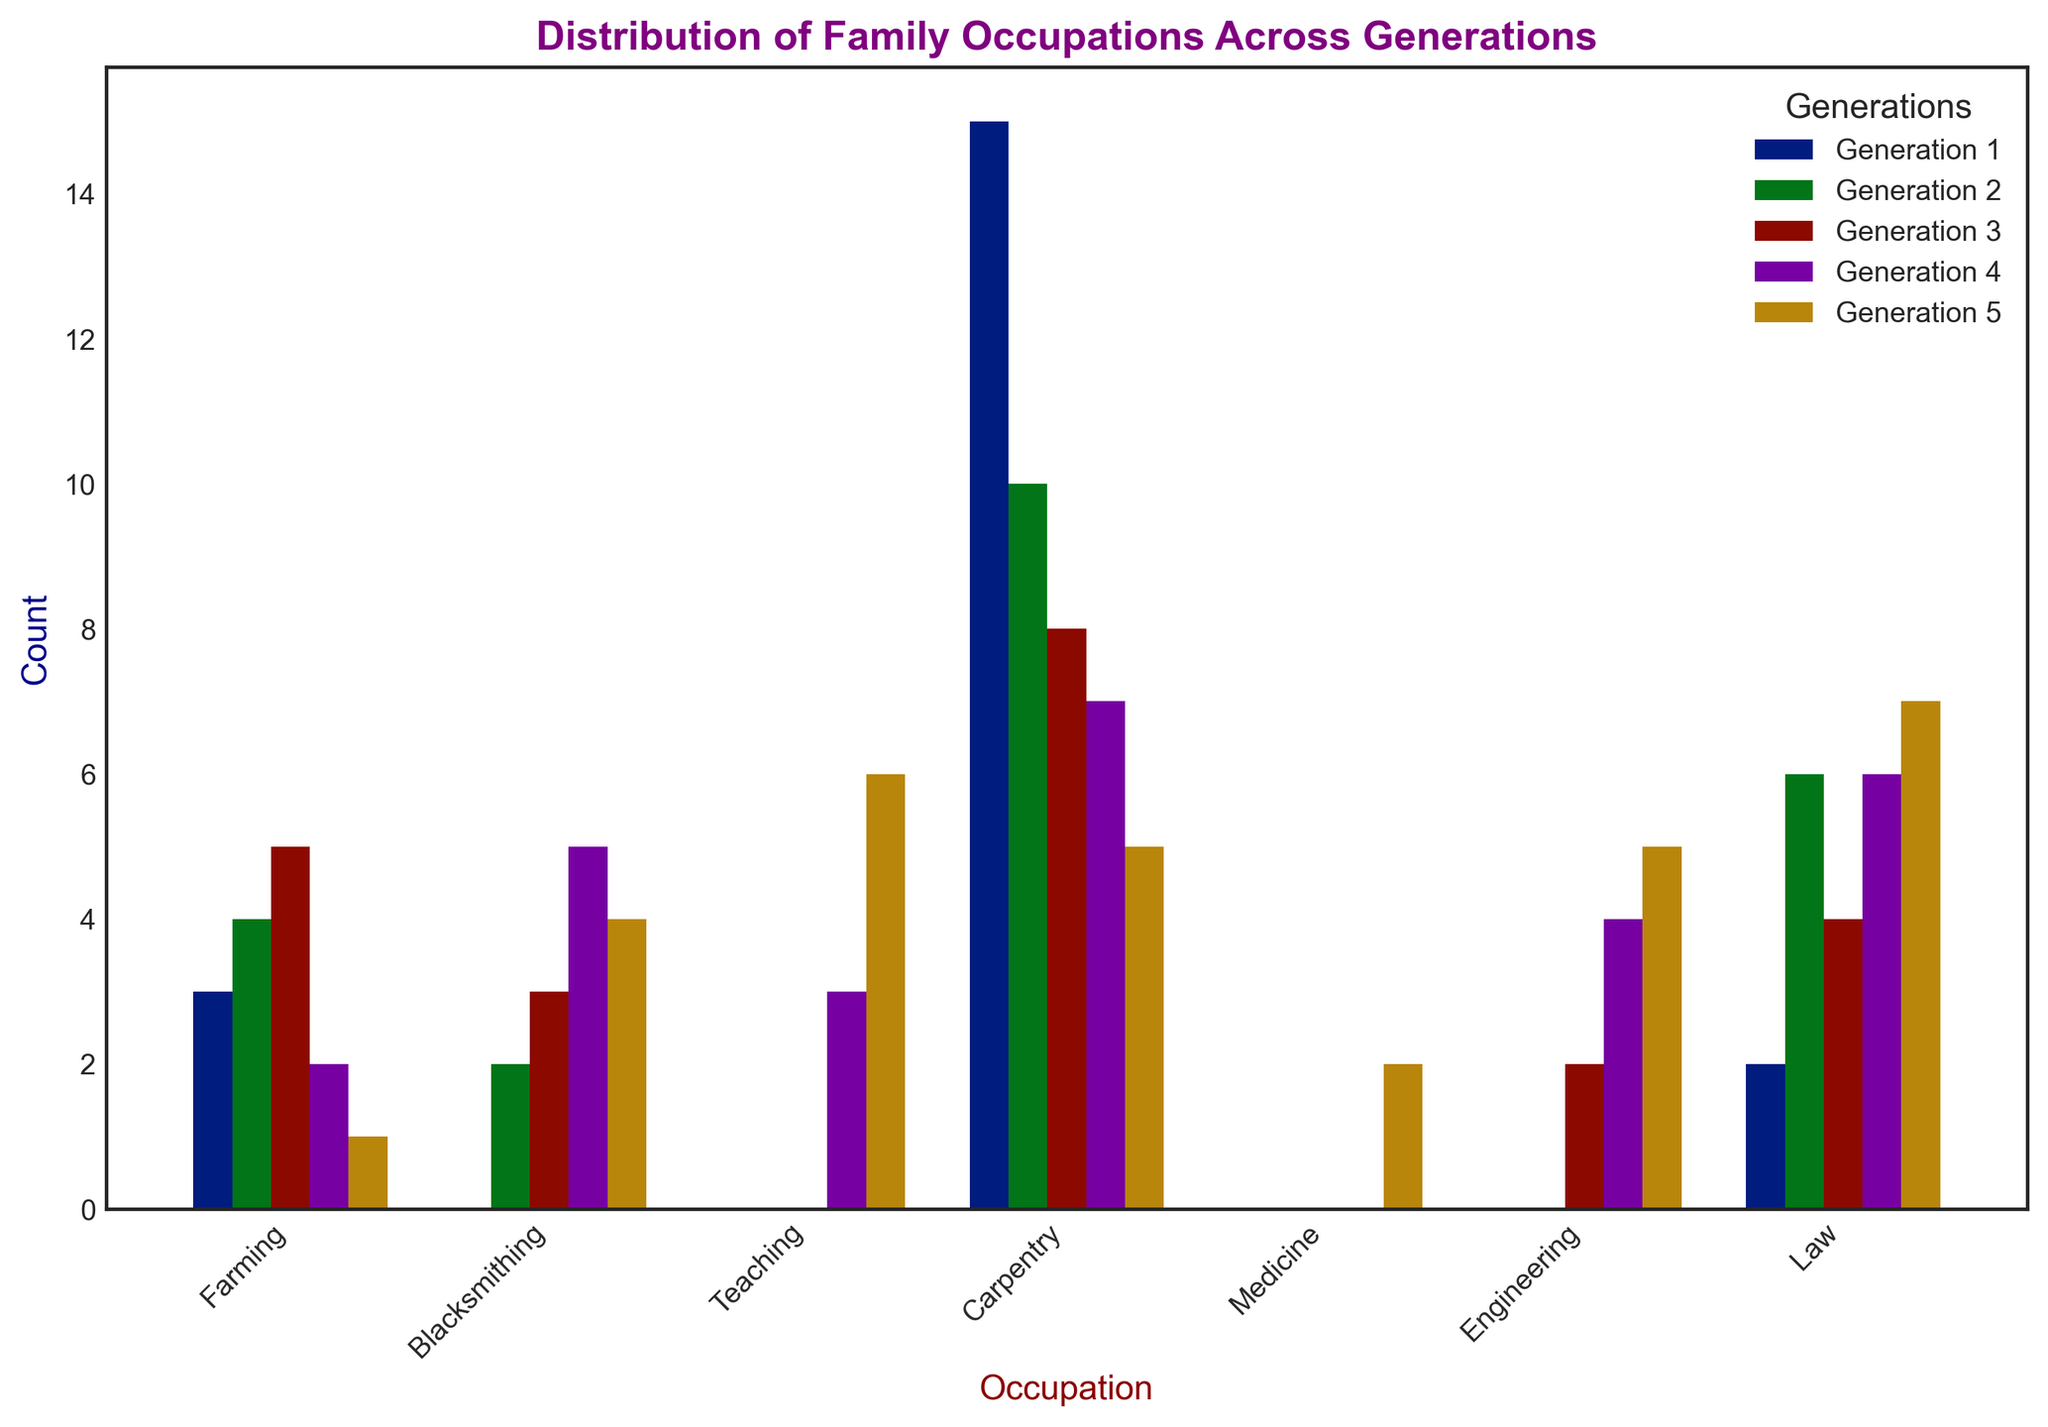What is the total number of Farming occupations across all generations? To find the total number of Farming occupations, sum the counts of Farming for each generation: 15 (Gen 1) + 10 (Gen 2) + 8 (Gen 3) + 7 (Gen 4) + 5 (Gen 5). The total is 15 + 10 + 8 + 7 + 5 = 45.
Answer: 45 Which generation has the highest count in Teaching occupations? Compare the counts of Teaching across all generations: Gen 1 (2), Gen 2 (6), Gen 3 (4), Gen 4 (6), Gen 5 (7). Generation 5 has the highest count with 7.
Answer: Generation 5 Is there any generation where the count of Medicine occupations exceeds the count of Carpentry occupations? Compare the counts of Medicine and Carpentry for each generation: Gen 3 (2 Medicine < 3 Carpentry), Gen 4 (4 Medicine < 5 Carpentry). Gen 5 is the only one with Medicine (5) > Carpentry (4).
Answer: Generation 5 Across all generations, which occupation shows the most significant increase in count from one generation to the next? Track the count increases across generations for each occupation:
- Blacksmithing: +1 (Gen 1 to Gen 2), +1 (Gen 2 to Gen 3), -3 (Gen 3 to Gen 4), -1 (Gen 4 to Gen 5)
- Carpentry: +2 (Gen 2 to Gen 3), +2 (Gen 3 to Gen 4), -1 (Gen 4 to Gen 5)
- Engineering: Starts in Gen 4 +3, +3 (Gen 4 to Gen 5)
- Farming: -5 (Gen 1 to Gen 2), -2 (Gen 2 to Gen 3), -1 (Gen 3 to Gen 4), -2 (Gen 4 to Gen 5)
- Law: Starts in Gen 5 +2
- Medicine: Starts in Gen 3 +2, +2 (Gen 3 to Gen 4), +1 (Gen 4 to Gen 5)
- Teaching: +4 (Gen 1 to Gen 2), -2 (Gen 2 to Gen 3), +2 (Gen 3 to Gen 4), +1 (Gen 4 to Gen 5)
Engineering shows the most significant increase (+3 from Gen 4 to Gen 5).
Answer: Engineering (Gen 4 to Gen 5) What is the sum of the counts for all occupations in Generation 4? Add the counts of all occupations in Generation 4: 
7 (Farming) + 2 (Blacksmithing) + 6 (Teaching) + 5 (Carpentry) + 4 (Medicine) + 3 (Engineering) = 7 + 2 + 6 + 5 + 4 + 3 = 27.
Answer: 27 Which occupation had the lowest count in Generation 5? Compare the counts of all occupations in Generation 5: Farming (5), Blacksmithing (1), Teaching (7), Carpentry (4), Medicine (5), Engineering (6), Law (2). Blacksmithing has the lowest count with 1.
Answer: Blacksmithing Visually, which generation is represented by the color blue in the bar chart? The legend in the bar chart shows that Generation 5 is represented by the color blue.
Answer: Generation 5 